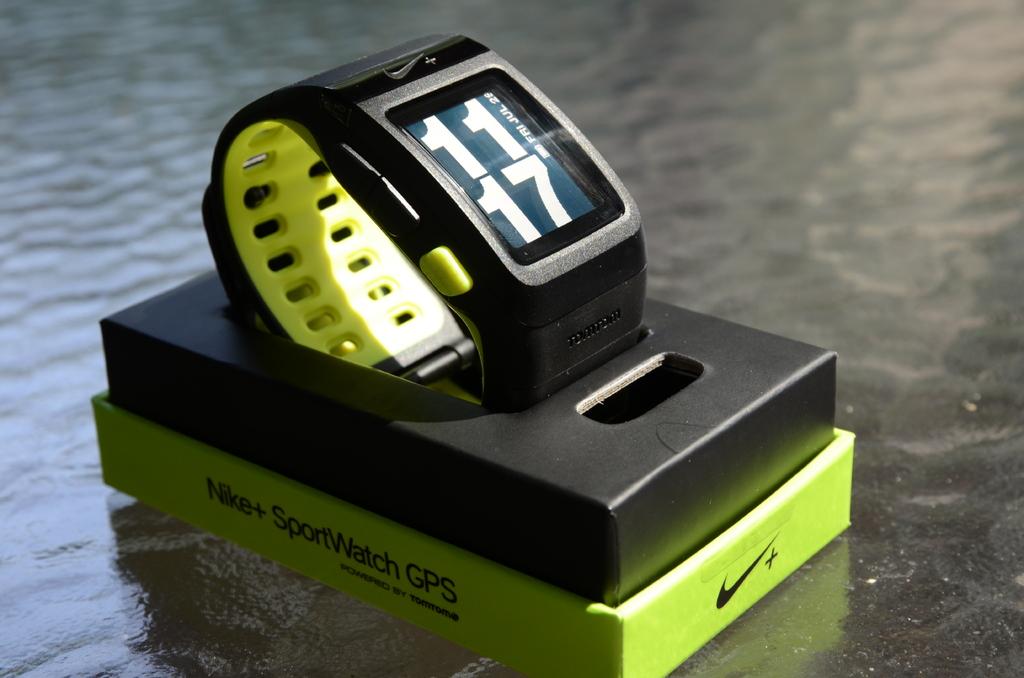What uses for watch?
Provide a short and direct response. Sport. What time is on the watch?
Keep it short and to the point. 11:17. 